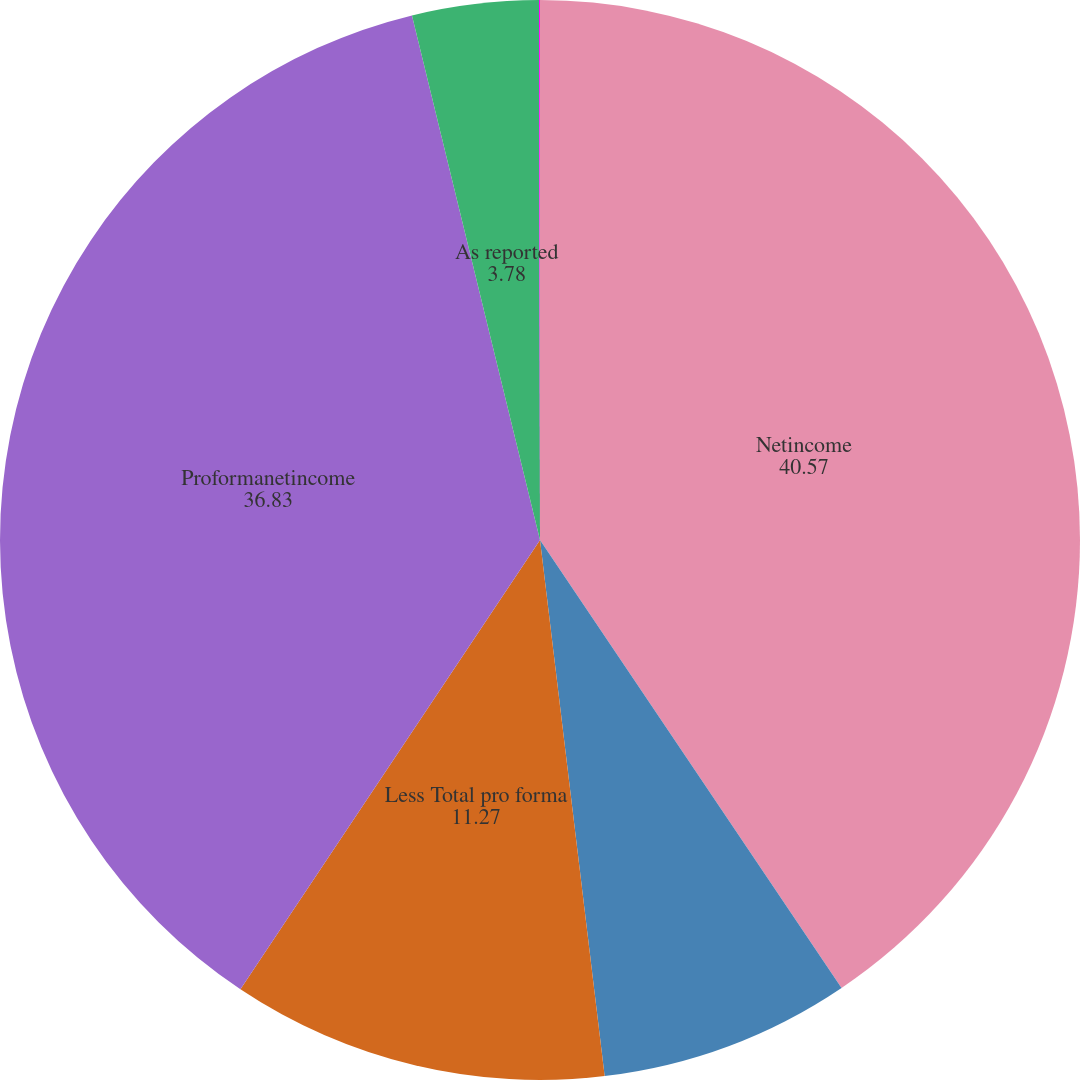Convert chart. <chart><loc_0><loc_0><loc_500><loc_500><pie_chart><fcel>Netincome<fcel>Add Stock-based employee<fcel>Less Total pro forma<fcel>Proformanetincome<fcel>As reported<fcel>Proforma<nl><fcel>40.57%<fcel>7.52%<fcel>11.27%<fcel>36.83%<fcel>3.78%<fcel>0.03%<nl></chart> 